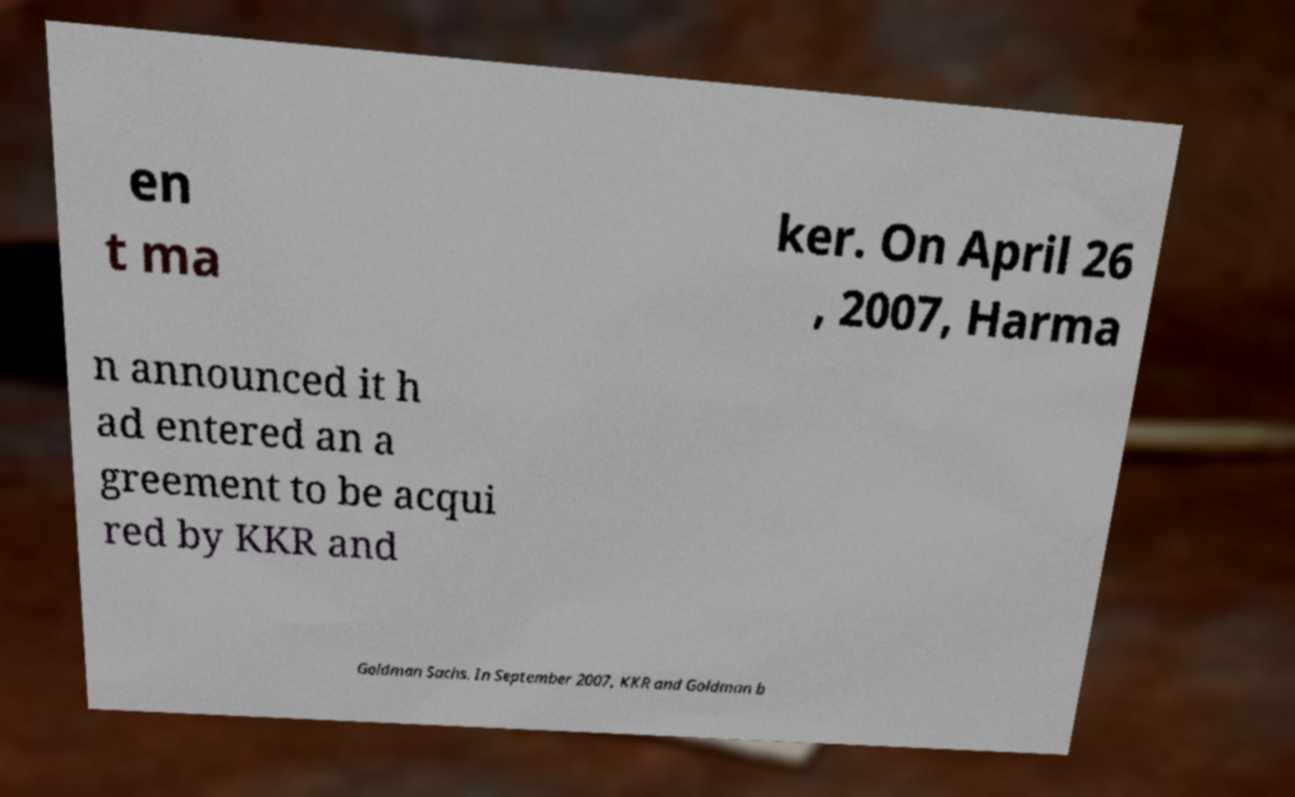There's text embedded in this image that I need extracted. Can you transcribe it verbatim? en t ma ker. On April 26 , 2007, Harma n announced it h ad entered an a greement to be acqui red by KKR and Goldman Sachs. In September 2007, KKR and Goldman b 